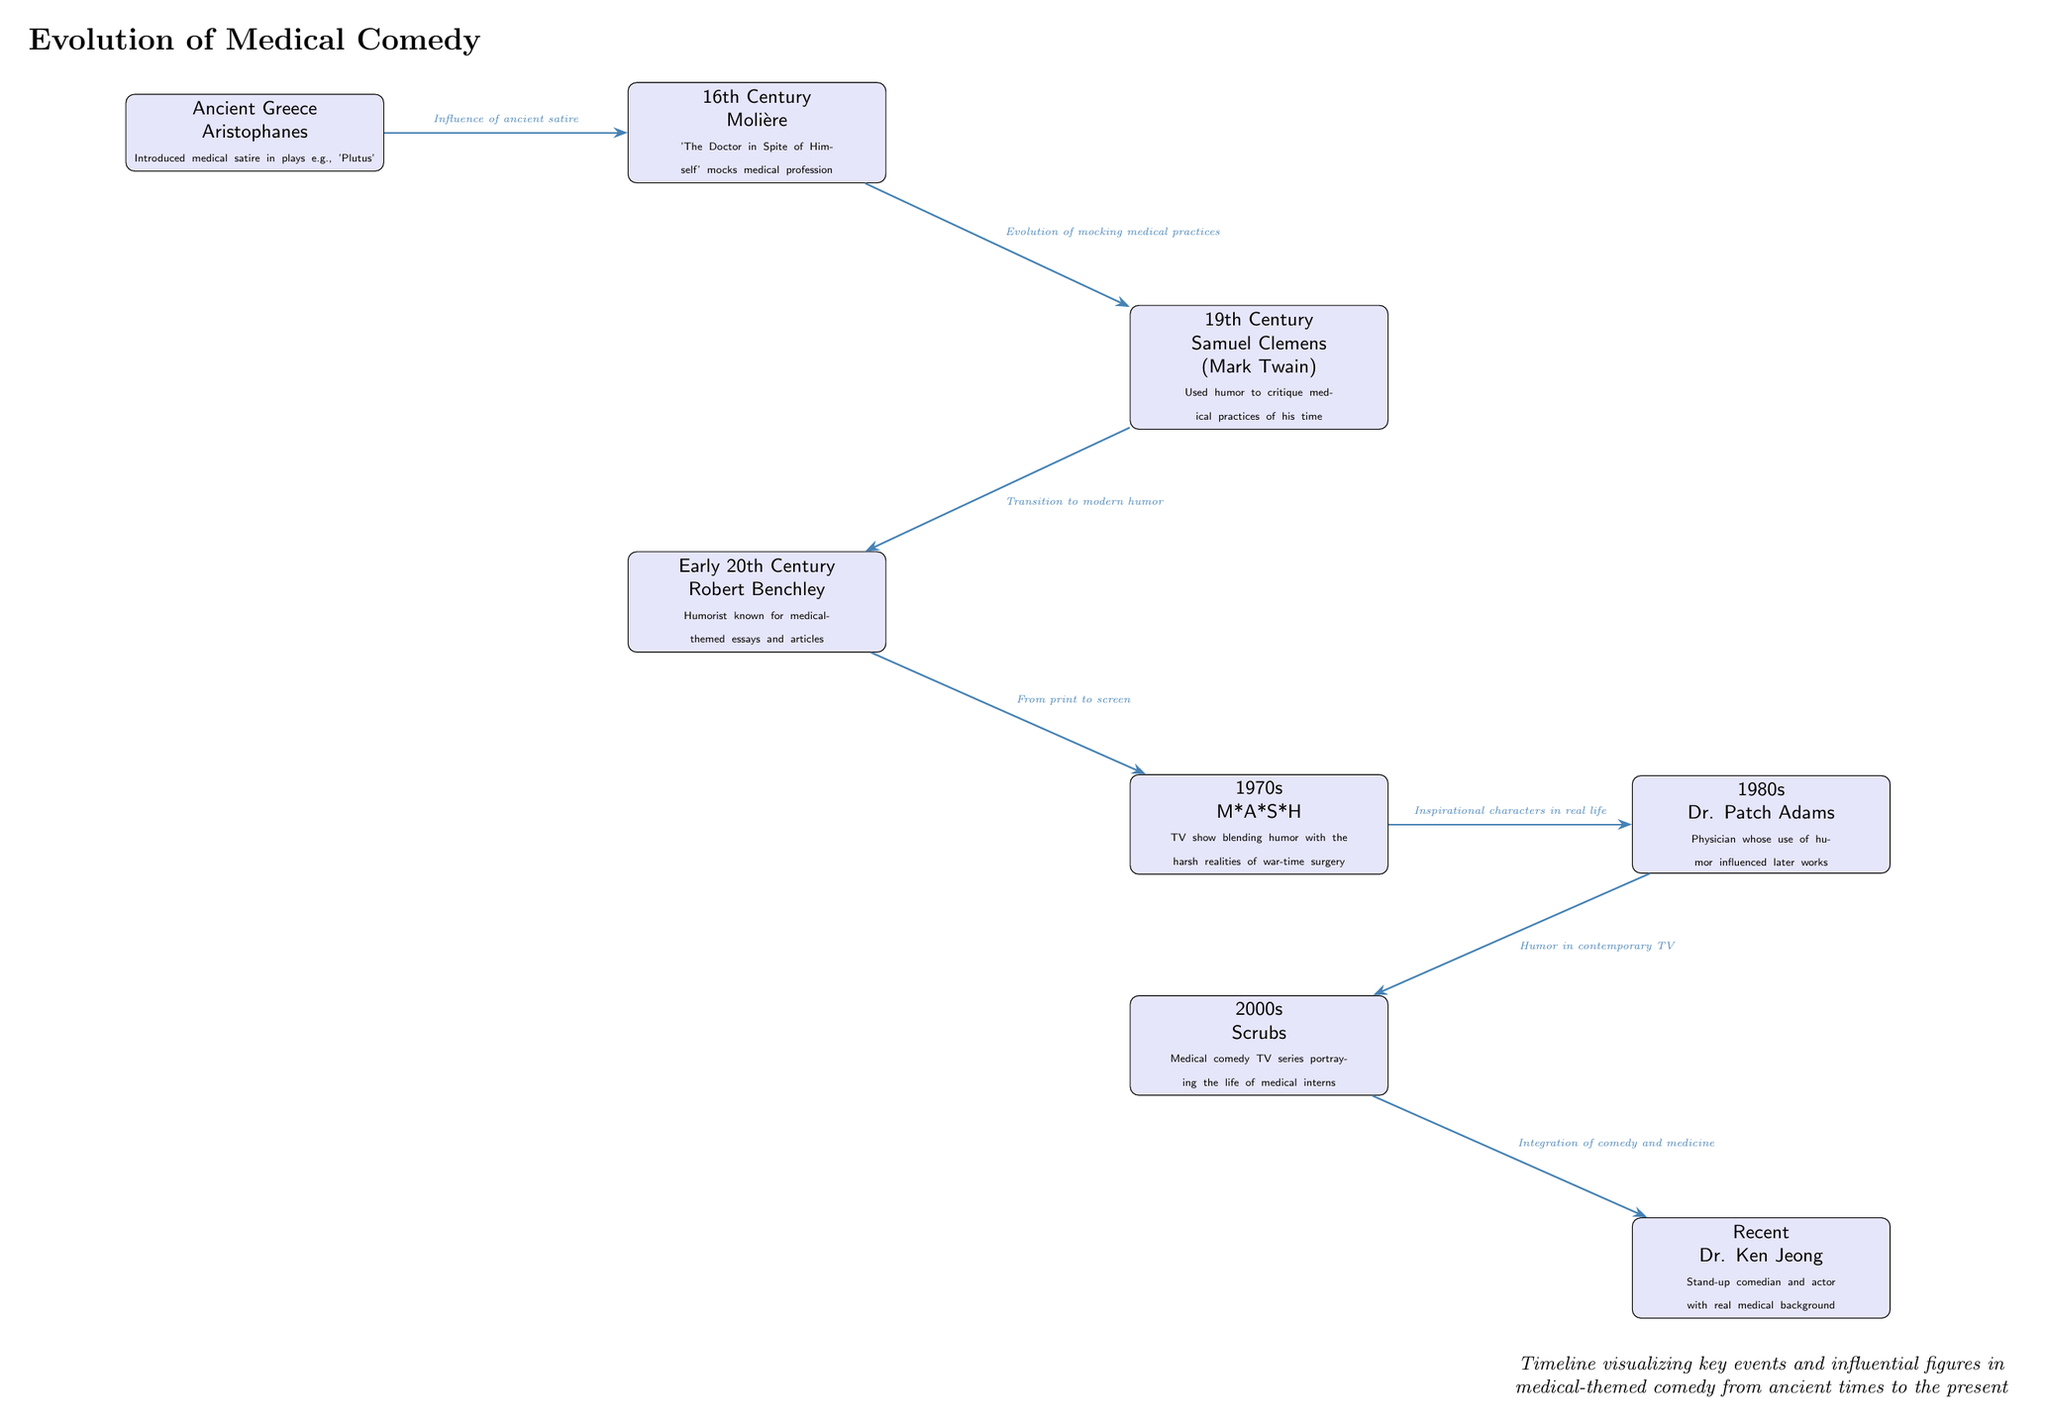What was introduced by Aristophanes in Ancient Greece? Aristophanes introduced medical satire in his plays, specifically noted in his work "Plutus." This reflects the evolution of humor within the medical context starting from ancient times.
Answer: medical satire Which influential figure is associated with the 16th Century? The figure associated with the 16th Century is Molière, known for his work "The Doctor in Spite of Himself," which mocks the medical profession. This connection highlights a significant transition in the portrayal of medical themes in comedy.
Answer: Molière What event connects the 19th Century humorist Samuel Clemens to Robert Benchley’s contributions? The event that connects these two figures is the evolution of mocking medical practices, where Clemens, also known as Mark Twain, critiqued medical practices, and Benchley wrote medical-themed essays. Thus, both contributed to medical comedy in their respective eras.
Answer: Evolution of mocking medical practices How many major events or figures are visualized in the diagram? To find the total number of major events or figures, count the nodes: there are eight significant nodes representing influential figures and events from ancient Greece to the recent era of Dr. Ken Jeong. Thus, the total count is eight.
Answer: 8 What transition is indicated by the edge from Robert Benchley to M*A*S*H? The edge from Robert Benchley to M*A*S*H indicates the transition from print to screen, suggesting how humor evolved from written format (essays) to television (the TV show M*A*S*H) by blending comedy with serious themes.
Answer: From print to screen Which two figures appear in the 2000s? The two figures in the 2000s are Scrubs and Dr. Ken Jeong, highlighting different aspects of medical-themed comedy during this decade, with Scrubs being a TV series about medical interns and Dr. Ken Jeong being a comedian with a medical background.
Answer: Scrubs and Dr. Ken Jeong What does the final node in the timeline represent? The final node in the timeline represents Dr. Ken Jeong, emphasizing his role as a stand-up comedian and actor with a real medical background, illustrating contemporary integration of humor and medicine in modern times.
Answer: Dr. Ken Jeong What theme does the connection from M*A*S*H to Dr. Patch Adams illustrate? The connection from M*A*S*H to Dr. Patch Adams illustrates the influence of inspirational characters in real life, showing how M*A*S*H inspired the comedic approach of Dr. Patch Adams, who utilized humor in his medical practice.
Answer: Inspirational characters in real life 